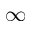Convert formula to latex. <formula><loc_0><loc_0><loc_500><loc_500>\infty</formula> 